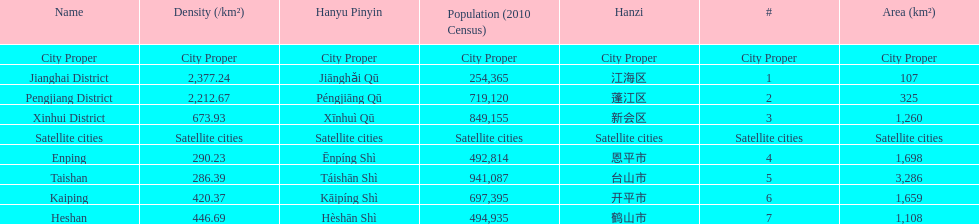Which area has the largest population? Taishan. 